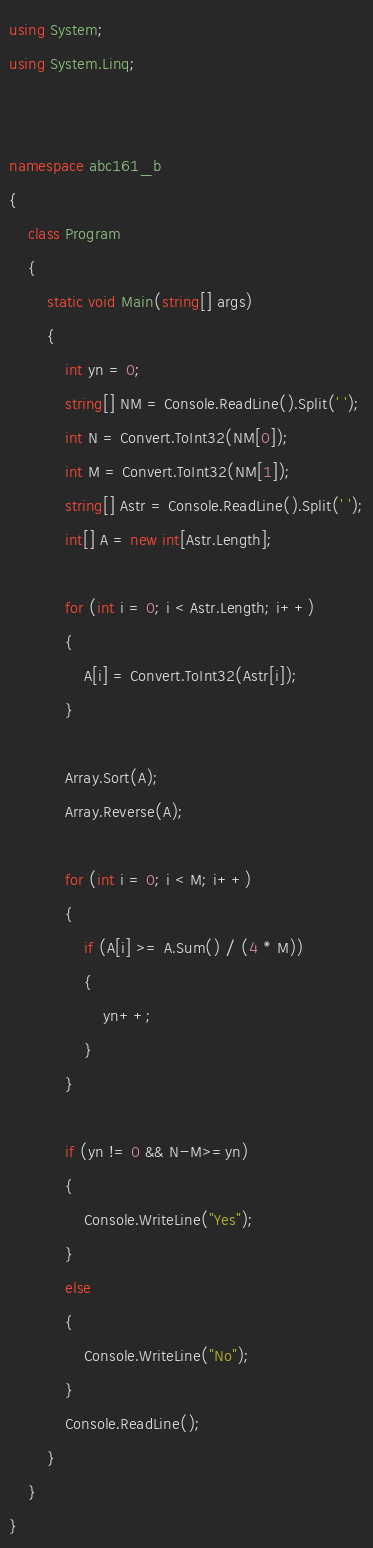<code> <loc_0><loc_0><loc_500><loc_500><_C#_>using System;
using System.Linq;


namespace abc161_b
{
    class Program
    {
        static void Main(string[] args)
        {
            int yn = 0;
            string[] NM = Console.ReadLine().Split(' ');
            int N = Convert.ToInt32(NM[0]);
            int M = Convert.ToInt32(NM[1]);
            string[] Astr = Console.ReadLine().Split(' ');
            int[] A = new int[Astr.Length];

            for (int i = 0; i < Astr.Length; i++)
            {
                A[i] = Convert.ToInt32(Astr[i]);
            }

            Array.Sort(A);
            Array.Reverse(A);

            for (int i = 0; i < M; i++)
            {
                if (A[i] >= A.Sum() / (4 * M))
                {
                    yn++;
                }
            }

            if (yn != 0 && N-M>=yn)
            {
                Console.WriteLine("Yes");
            }
            else
            {
                Console.WriteLine("No");
            }
            Console.ReadLine();
        }
    }
}
</code> 